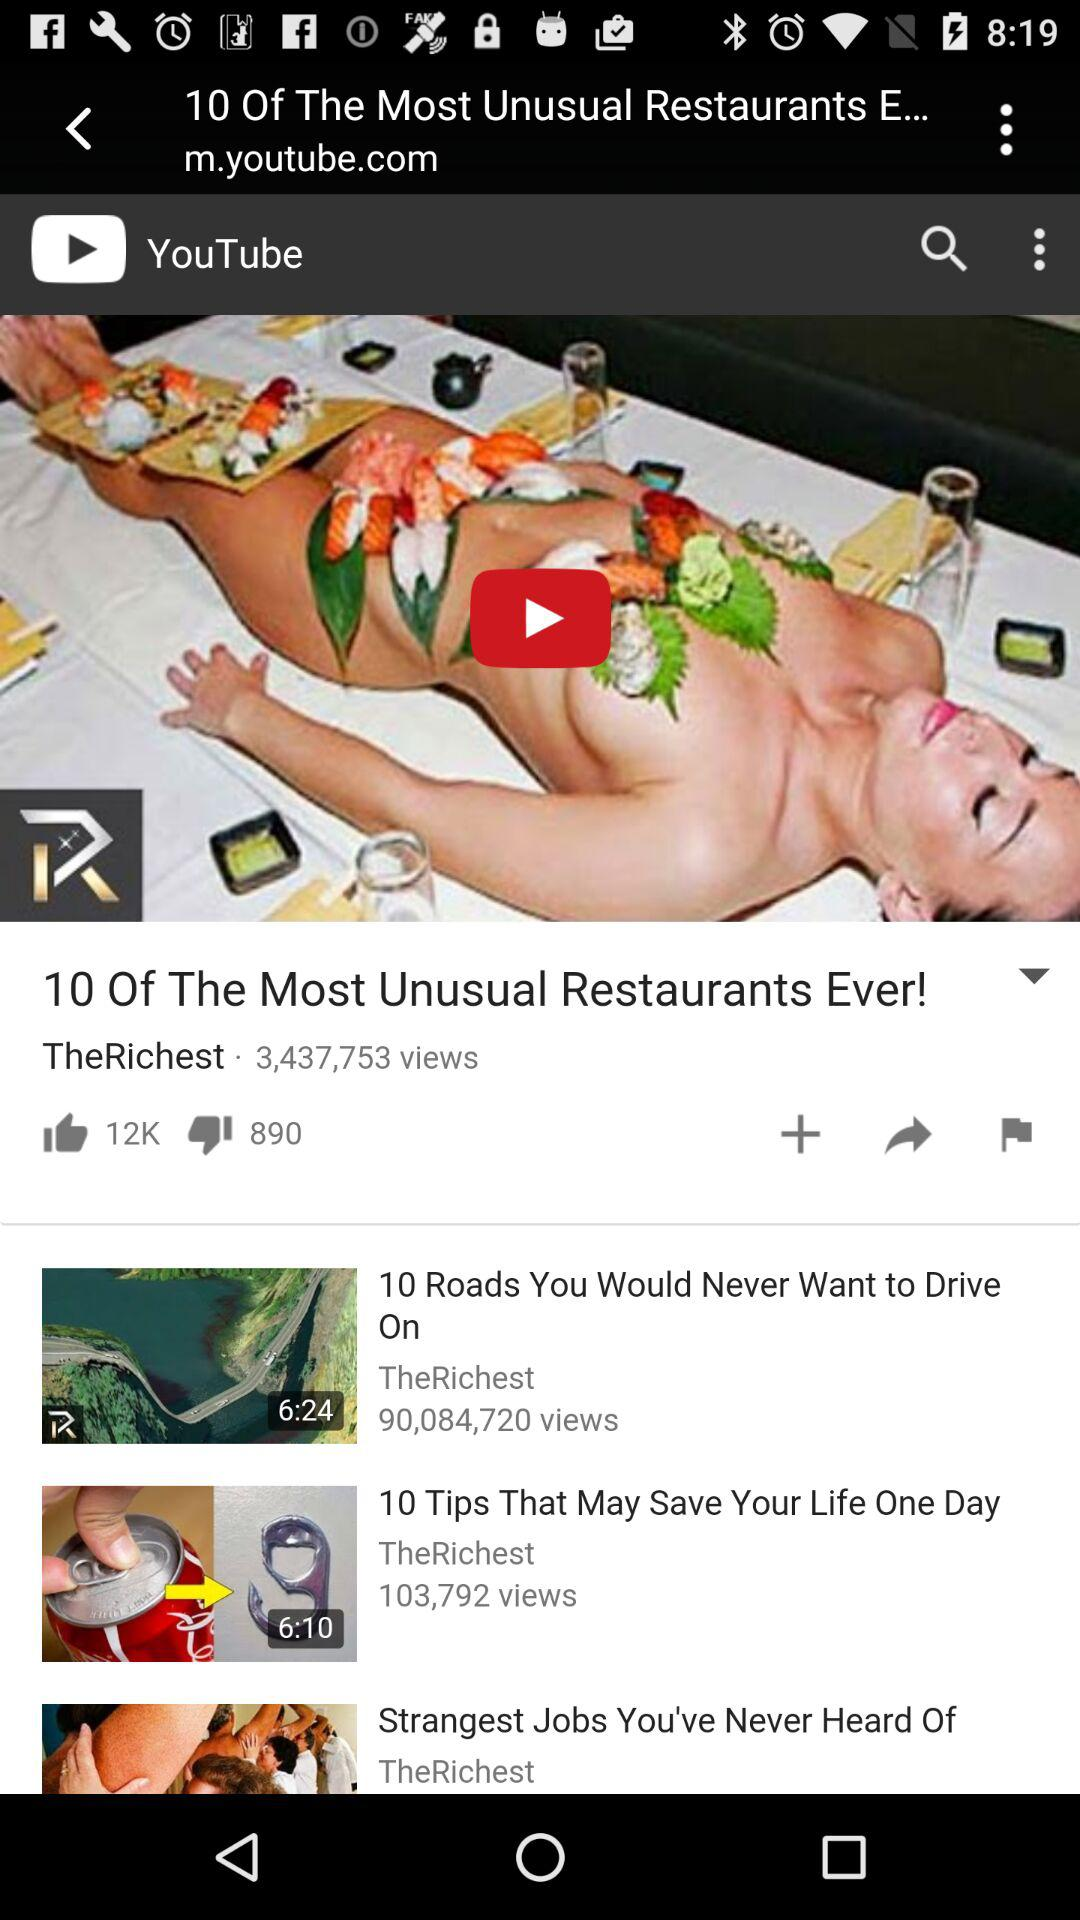How many likes are there of the "10 Of The Most Unusual Restaurants Ever!" video? There are 12,000 likes of the "10 Of The Most Unusual Restaurants Ever!" video. 